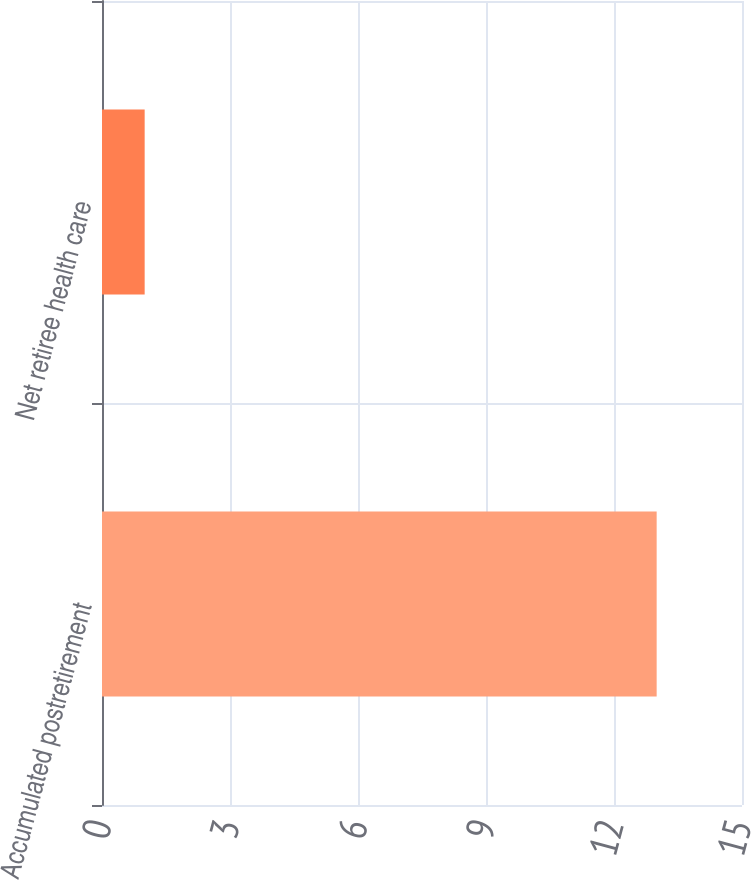<chart> <loc_0><loc_0><loc_500><loc_500><bar_chart><fcel>Accumulated postretirement<fcel>Net retiree health care<nl><fcel>13<fcel>1<nl></chart> 